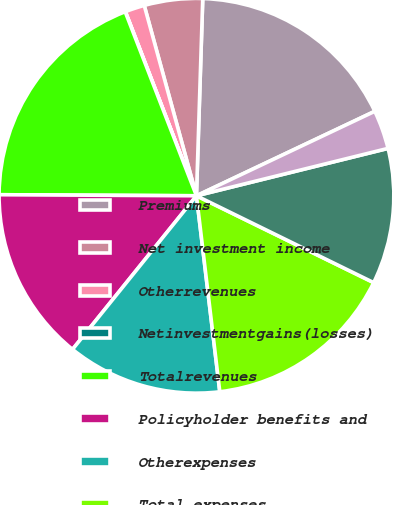Convert chart. <chart><loc_0><loc_0><loc_500><loc_500><pie_chart><fcel>Premiums<fcel>Net investment income<fcel>Otherrevenues<fcel>Netinvestmentgains(losses)<fcel>Totalrevenues<fcel>Policyholder benefits and<fcel>Otherexpenses<fcel>Total expenses<fcel>Income (loss) from continuing<fcel>Provision(benefit)forincometax<nl><fcel>17.45%<fcel>4.77%<fcel>1.6%<fcel>0.02%<fcel>19.03%<fcel>14.28%<fcel>12.69%<fcel>15.86%<fcel>11.11%<fcel>3.18%<nl></chart> 